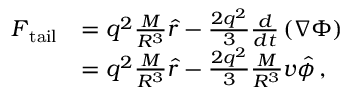Convert formula to latex. <formula><loc_0><loc_0><loc_500><loc_500>\begin{array} { r l } { F _ { t a i l } } & { = q ^ { 2 } \frac { M } { R ^ { 3 } } \hat { r } - \frac { 2 q ^ { 2 } } { 3 } \frac { d } { d t } \left ( \nabla \Phi \right ) } \\ & { = q ^ { 2 } \frac { M } { R ^ { 3 } } \hat { r } - \frac { 2 q ^ { 2 } } { 3 } \frac { M } { R ^ { 3 } } v \hat { \phi } \, , } \end{array}</formula> 